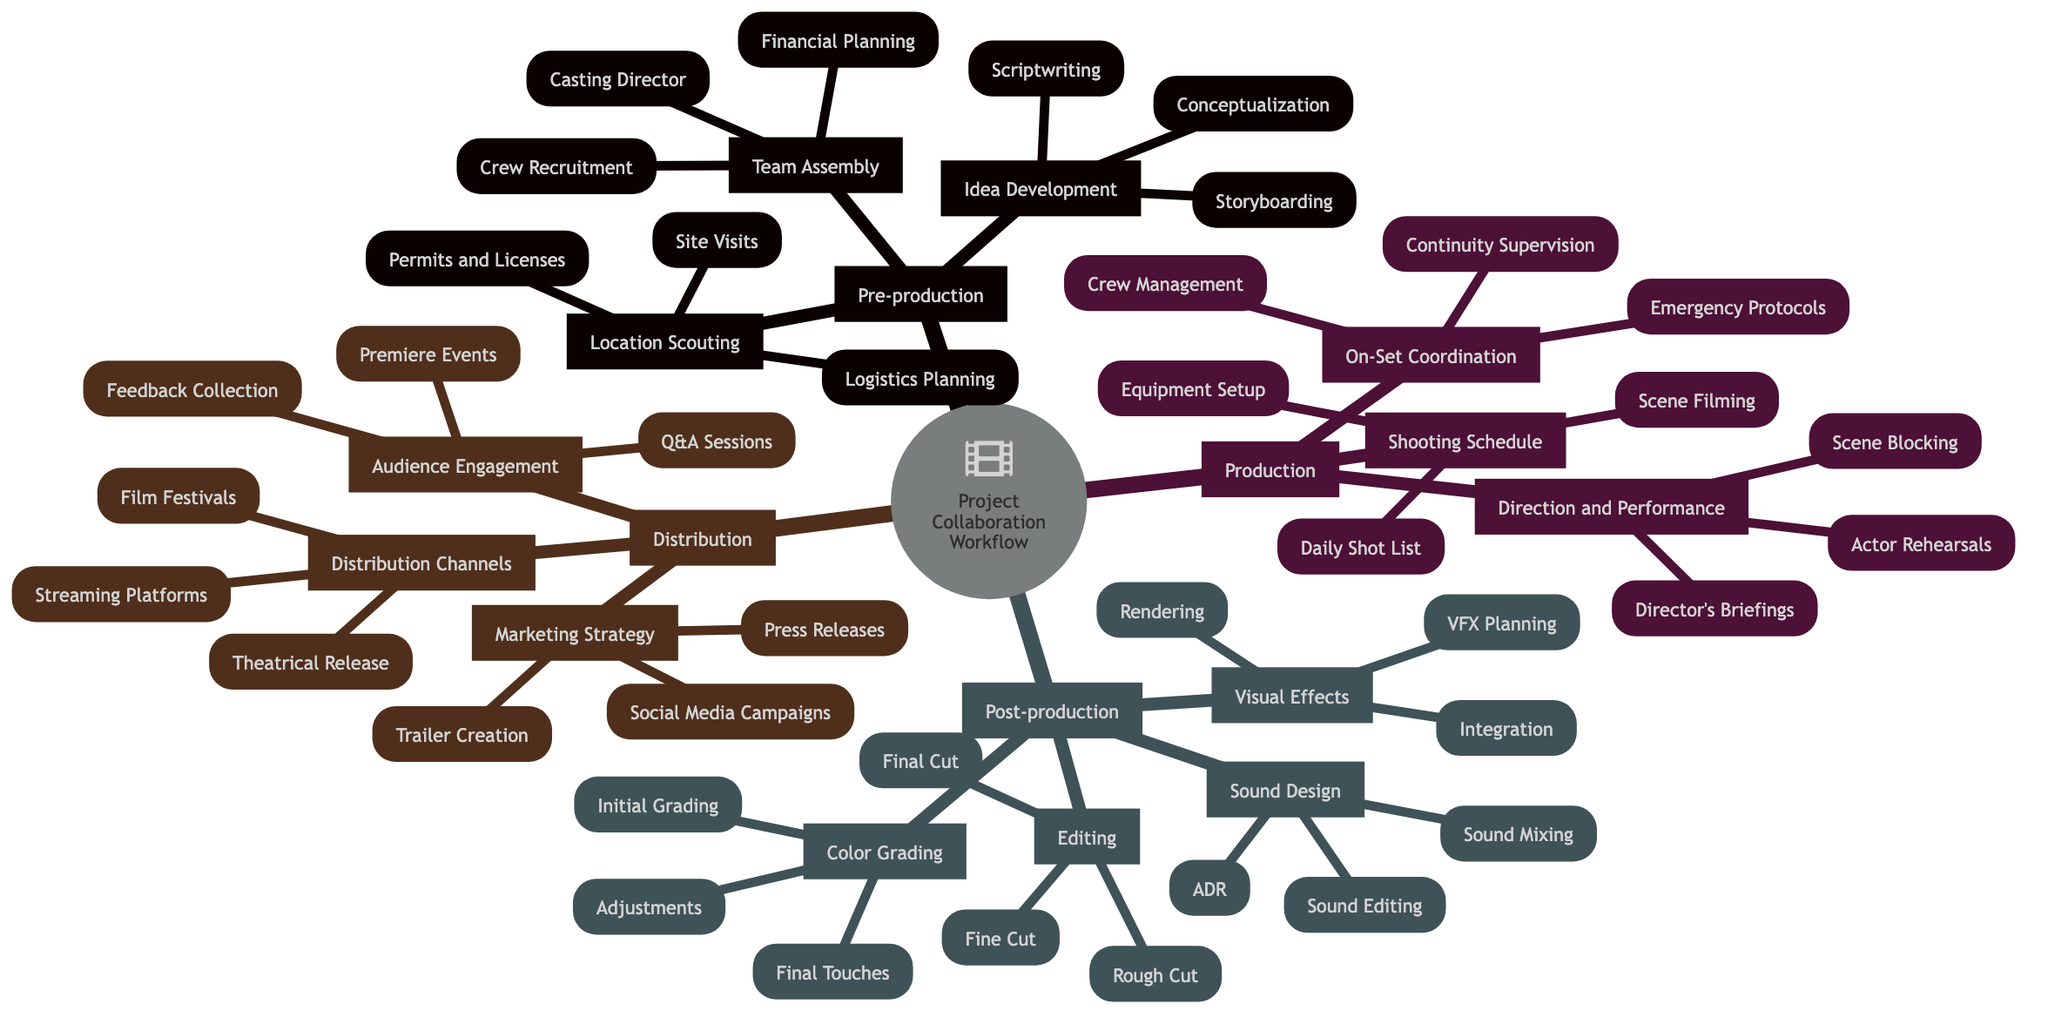What are the three main stages in the project collaboration workflow? The diagram shows four main stages: Pre-production, Production, Post-production, and Distribution. These are the high-level categories that organize the workflow.
Answer: Pre-production, Production, Post-production, Distribution How many tasks are involved in the "Location Scouting" phase? Under the "Location Scouting" section, there are three specific tasks listed: Site Visits, Permits and Licenses, and Logistics Planning. Therefore, the number of tasks is counted directly from these listed items.
Answer: 3 What is the first task listed under "Editing"? The first task in the Editing phase is listed as "Rough Cut." This information can be observed directly in the diagram under the Editing section.
Answer: Rough Cut Which task comes after "Actor Rehearsals" in the "Direction and Performance" section? In the "Direction and Performance" section, the tasks follow the order: Director's Briefings, Actor Rehearsals, and then Scene Blocking. By examining the flow of tasks, Scene Blocking follows after Actor Rehearsals.
Answer: Scene Blocking How many tasks are there in total for "Distribution"? The Distribution stage consists of three main tasks: Marketing Strategy, Distribution Channels, and Audience Engagement. Each of these sections further contains three tasks as well, which can be counted for a total. Overall, there are 3 actions for the first level and 9 for the second level: 3 + 9 = 12.
Answer: 12 Which section includes the task "VFX Planning"? The task "VFX Planning" is included under the "Visual Effects" section within the Post-production stage. This can be identified in the hierarchy shown in the diagram.
Answer: Visual Effects How many sub-sections are found under "Post-production"? Under the Post-production section, there are four sub-sections: Editing, Sound Design, Visual Effects, and Color Grading. By counting each individual category listed here, we can provide the total number of sub-sections.
Answer: 4 What is the last task listed under "Color Grading"? The last task in the Color Grading section is "Final Touches." This can be seen at the end of the list of tasks within that specific section of the diagram.
Answer: Final Touches What phase does "Trailer Creation" belong to? The task "Trailer Creation" is part of the Marketing Strategy in the Distribution phase. This can be verified by tracing the task back through the hierarchical structure to its corresponding section.
Answer: Marketing Strategy 